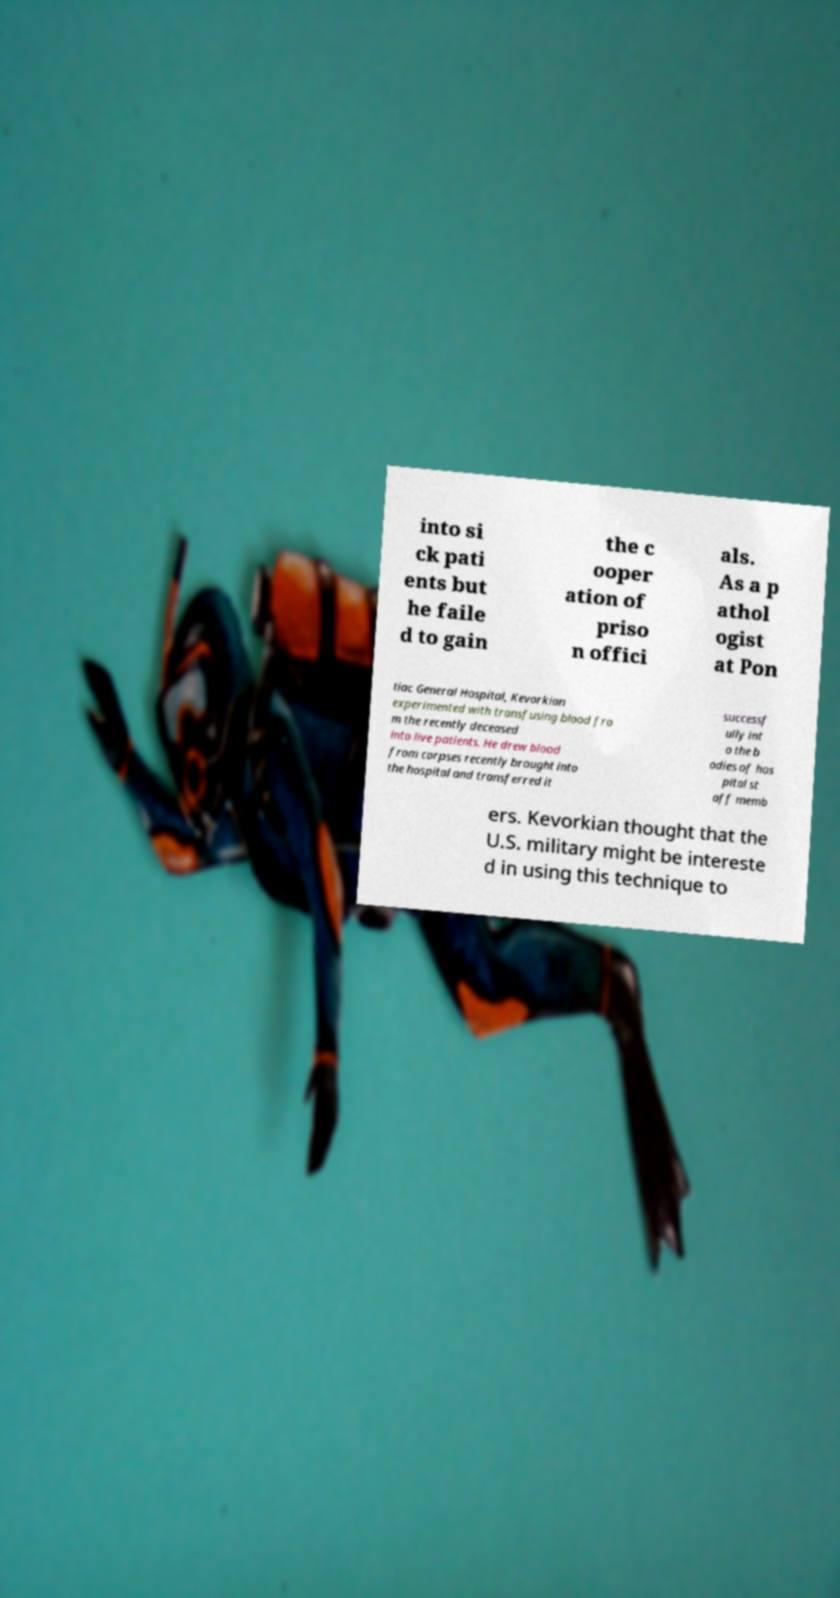Can you read and provide the text displayed in the image?This photo seems to have some interesting text. Can you extract and type it out for me? into si ck pati ents but he faile d to gain the c ooper ation of priso n offici als. As a p athol ogist at Pon tiac General Hospital, Kevorkian experimented with transfusing blood fro m the recently deceased into live patients. He drew blood from corpses recently brought into the hospital and transferred it successf ully int o the b odies of hos pital st aff memb ers. Kevorkian thought that the U.S. military might be intereste d in using this technique to 